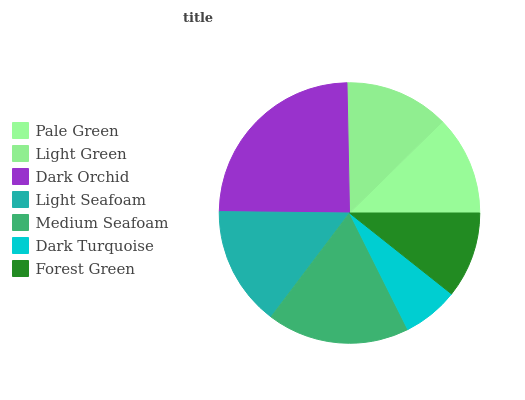Is Dark Turquoise the minimum?
Answer yes or no. Yes. Is Dark Orchid the maximum?
Answer yes or no. Yes. Is Light Green the minimum?
Answer yes or no. No. Is Light Green the maximum?
Answer yes or no. No. Is Light Green greater than Pale Green?
Answer yes or no. Yes. Is Pale Green less than Light Green?
Answer yes or no. Yes. Is Pale Green greater than Light Green?
Answer yes or no. No. Is Light Green less than Pale Green?
Answer yes or no. No. Is Light Green the high median?
Answer yes or no. Yes. Is Light Green the low median?
Answer yes or no. Yes. Is Light Seafoam the high median?
Answer yes or no. No. Is Dark Turquoise the low median?
Answer yes or no. No. 